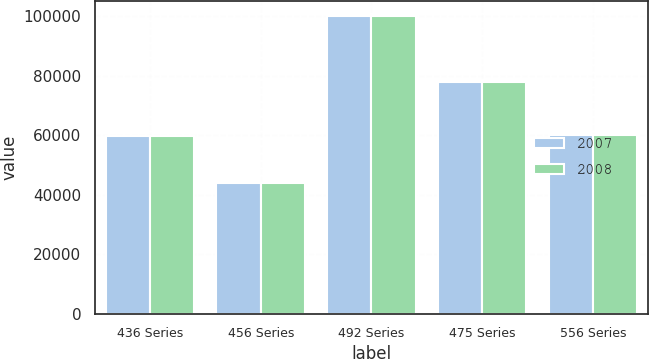Convert chart. <chart><loc_0><loc_0><loc_500><loc_500><stacked_bar_chart><ecel><fcel>436 Series<fcel>456 Series<fcel>492 Series<fcel>475 Series<fcel>556 Series<nl><fcel>2007<fcel>59920<fcel>43887<fcel>100000<fcel>77798<fcel>60000<nl><fcel>2008<fcel>59920<fcel>43887<fcel>100000<fcel>77798<fcel>60000<nl></chart> 